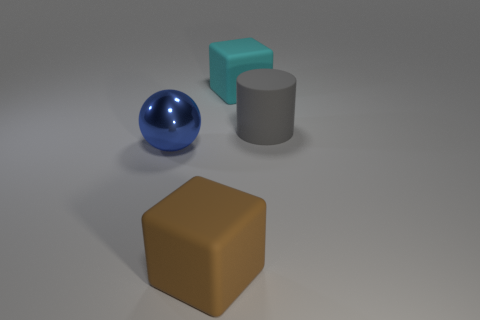Add 3 large gray rubber cylinders. How many objects exist? 7 Subtract all spheres. How many objects are left? 3 Subtract 0 yellow balls. How many objects are left? 4 Subtract all rubber cylinders. Subtract all large blue things. How many objects are left? 2 Add 1 blue metallic spheres. How many blue metallic spheres are left? 2 Add 1 large gray rubber cylinders. How many large gray rubber cylinders exist? 2 